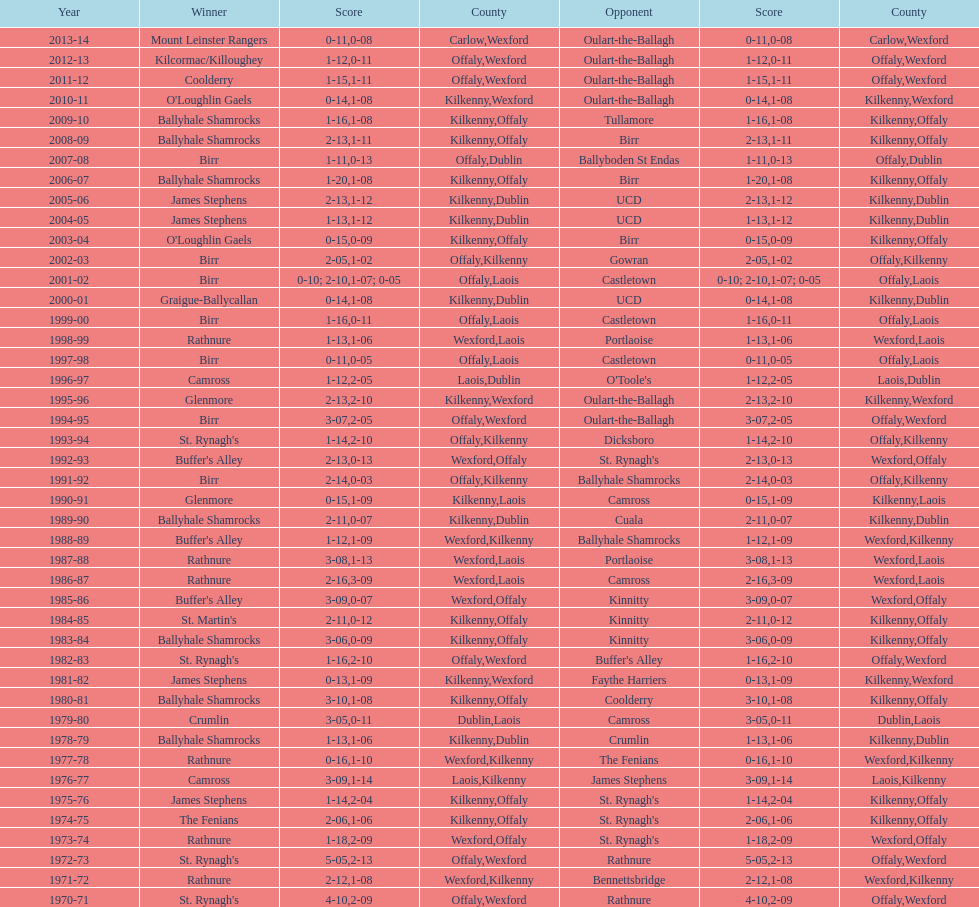In which final season did the leinster senior club hurling championships have a winning margin of less than 11 points? 2007-08. 